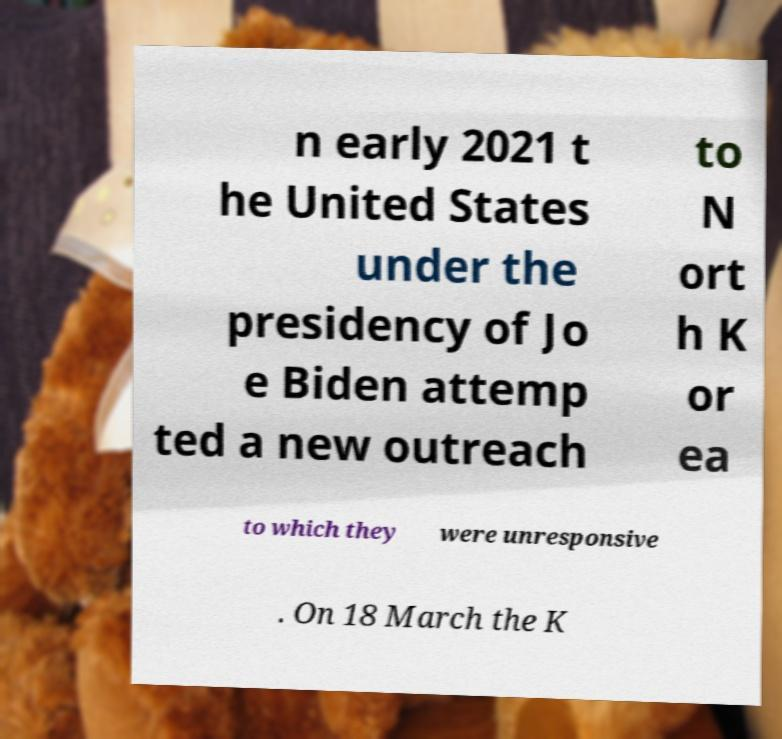There's text embedded in this image that I need extracted. Can you transcribe it verbatim? n early 2021 t he United States under the presidency of Jo e Biden attemp ted a new outreach to N ort h K or ea to which they were unresponsive . On 18 March the K 